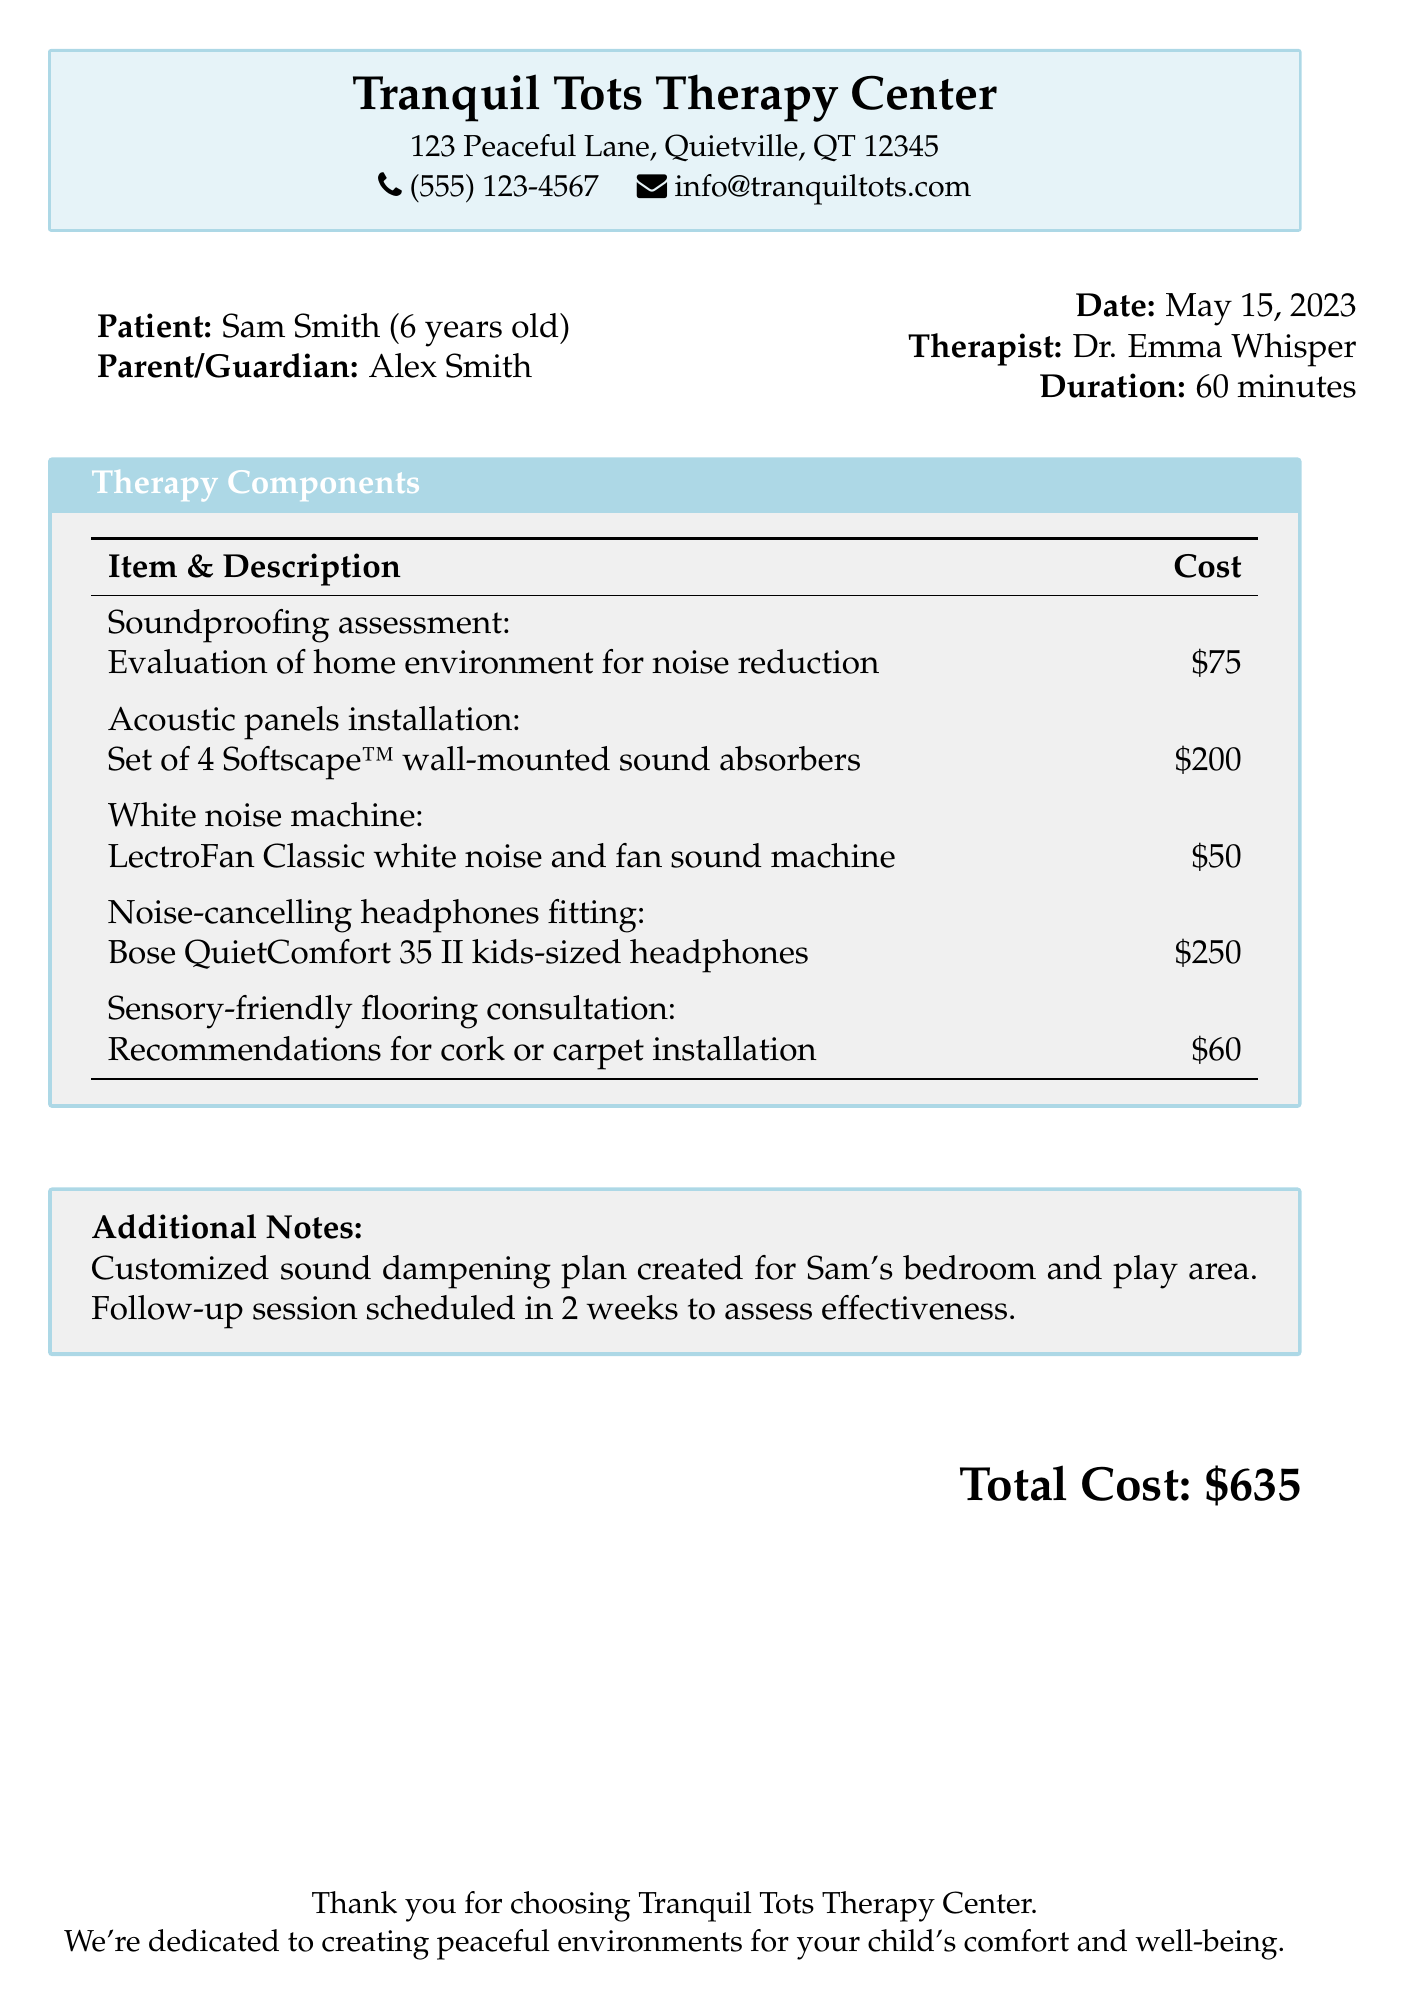what is the name of the therapy center? The therapy center is identified as Tranquil Tots Therapy Center in the document.
Answer: Tranquil Tots Therapy Center who is the patient? The document states that the patient is Sam Smith, who is 6 years old.
Answer: Sam Smith what was the total cost of the therapy session? The total cost is detailed as the sum of all charges listed in the bill.
Answer: $635 what equipment was installed for soundproofing? The document lists a set of Softscape™ wall-mounted sound absorbers for soundproofing.
Answer: Softscape™ wall-mounted sound absorbers who conducted the therapy session? The therapist is mentioned as Dr. Emma Whisper in the document.
Answer: Dr. Emma Whisper what additional consultation was provided? The bill includes a consultation for recommendations for cork or carpet installation.
Answer: Sensory-friendly flooring consultation how long was the therapy session? The duration of the therapy session is specified in the document as 60 minutes.
Answer: 60 minutes when is the follow-up session scheduled? The follow-up session is scheduled in two weeks as stated in the document.
Answer: 2 weeks what is the location of the therapy center? The document specifies that the therapy center is located at 123 Peaceful Lane, Quietville, QT 12345.
Answer: 123 Peaceful Lane, Quietville, QT 12345 